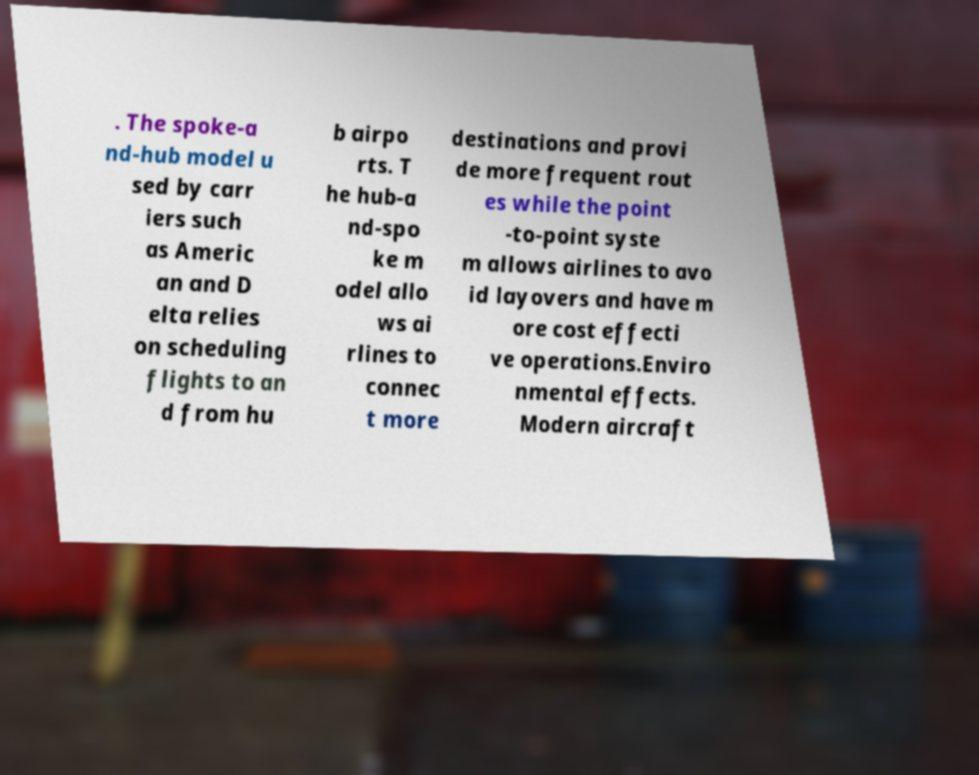I need the written content from this picture converted into text. Can you do that? . The spoke-a nd-hub model u sed by carr iers such as Americ an and D elta relies on scheduling flights to an d from hu b airpo rts. T he hub-a nd-spo ke m odel allo ws ai rlines to connec t more destinations and provi de more frequent rout es while the point -to-point syste m allows airlines to avo id layovers and have m ore cost effecti ve operations.Enviro nmental effects. Modern aircraft 